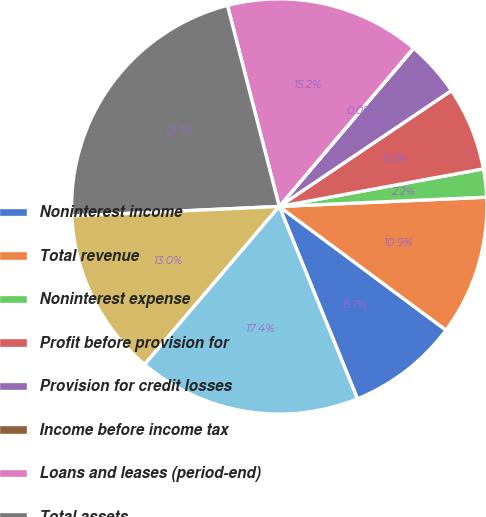<chart> <loc_0><loc_0><loc_500><loc_500><pie_chart><fcel>Noninterest income<fcel>Total revenue<fcel>Noninterest expense<fcel>Profit before provision for<fcel>Provision for credit losses<fcel>Income before income tax<fcel>Loans and leases (period-end)<fcel>Total assets<fcel>Total loans and leases<fcel>Deposits<nl><fcel>8.7%<fcel>10.87%<fcel>2.19%<fcel>6.53%<fcel>4.36%<fcel>0.02%<fcel>15.21%<fcel>21.72%<fcel>13.04%<fcel>17.38%<nl></chart> 